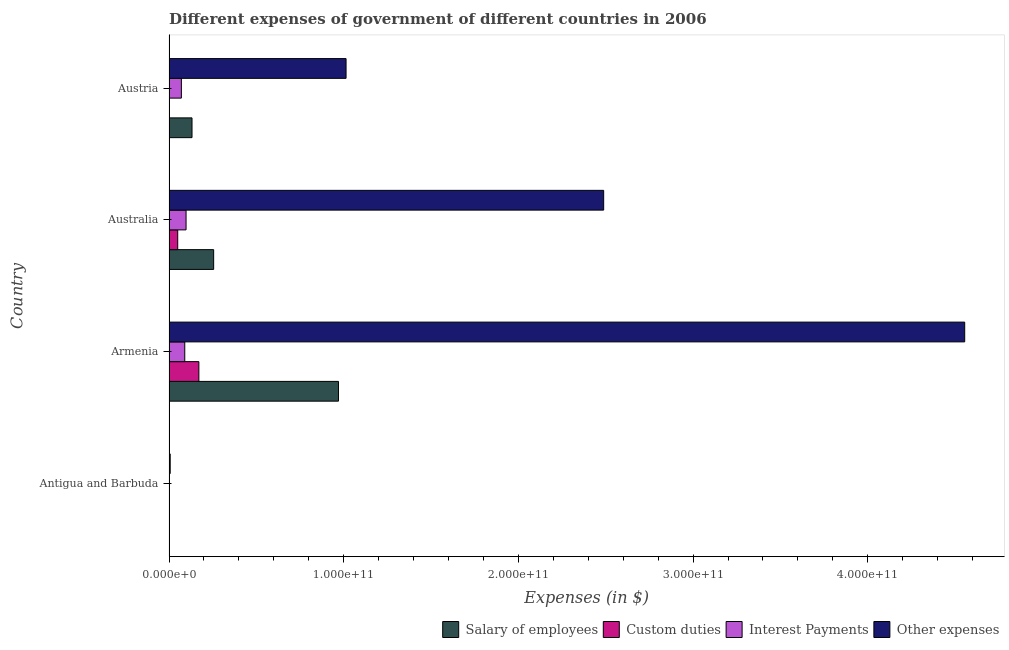How many different coloured bars are there?
Your answer should be compact. 4. How many groups of bars are there?
Keep it short and to the point. 4. Are the number of bars per tick equal to the number of legend labels?
Your answer should be very brief. Yes. Are the number of bars on each tick of the Y-axis equal?
Provide a short and direct response. Yes. In how many cases, is the number of bars for a given country not equal to the number of legend labels?
Your response must be concise. 0. What is the amount spent on custom duties in Armenia?
Make the answer very short. 1.71e+1. Across all countries, what is the maximum amount spent on custom duties?
Provide a succinct answer. 1.71e+1. Across all countries, what is the minimum amount spent on salary of employees?
Make the answer very short. 2.68e+08. In which country was the amount spent on custom duties maximum?
Your answer should be very brief. Armenia. In which country was the amount spent on other expenses minimum?
Give a very brief answer. Antigua and Barbuda. What is the total amount spent on interest payments in the graph?
Your response must be concise. 2.60e+1. What is the difference between the amount spent on custom duties in Antigua and Barbuda and that in Austria?
Give a very brief answer. 8.22e+07. What is the difference between the amount spent on interest payments in Austria and the amount spent on other expenses in Antigua and Barbuda?
Provide a short and direct response. 6.40e+09. What is the average amount spent on salary of employees per country?
Make the answer very short. 3.40e+1. What is the difference between the amount spent on salary of employees and amount spent on interest payments in Antigua and Barbuda?
Your response must be concise. 1.70e+08. In how many countries, is the amount spent on salary of employees greater than 300000000000 $?
Provide a succinct answer. 0. What is the ratio of the amount spent on interest payments in Australia to that in Austria?
Provide a succinct answer. 1.38. Is the difference between the amount spent on other expenses in Armenia and Australia greater than the difference between the amount spent on interest payments in Armenia and Australia?
Your response must be concise. Yes. What is the difference between the highest and the second highest amount spent on interest payments?
Your response must be concise. 7.39e+08. What is the difference between the highest and the lowest amount spent on custom duties?
Offer a very short reply. 1.71e+1. In how many countries, is the amount spent on other expenses greater than the average amount spent on other expenses taken over all countries?
Offer a terse response. 2. Is the sum of the amount spent on interest payments in Antigua and Barbuda and Austria greater than the maximum amount spent on other expenses across all countries?
Your answer should be compact. No. Is it the case that in every country, the sum of the amount spent on salary of employees and amount spent on interest payments is greater than the sum of amount spent on other expenses and amount spent on custom duties?
Offer a terse response. No. What does the 4th bar from the top in Antigua and Barbuda represents?
Your answer should be very brief. Salary of employees. What does the 2nd bar from the bottom in Armenia represents?
Offer a terse response. Custom duties. Is it the case that in every country, the sum of the amount spent on salary of employees and amount spent on custom duties is greater than the amount spent on interest payments?
Your response must be concise. Yes. How many bars are there?
Provide a succinct answer. 16. How many countries are there in the graph?
Offer a terse response. 4. What is the difference between two consecutive major ticks on the X-axis?
Provide a succinct answer. 1.00e+11. Does the graph contain grids?
Keep it short and to the point. No. Where does the legend appear in the graph?
Keep it short and to the point. Bottom right. How are the legend labels stacked?
Provide a short and direct response. Horizontal. What is the title of the graph?
Your answer should be compact. Different expenses of government of different countries in 2006. Does "Social Assistance" appear as one of the legend labels in the graph?
Make the answer very short. No. What is the label or title of the X-axis?
Offer a terse response. Expenses (in $). What is the label or title of the Y-axis?
Provide a succinct answer. Country. What is the Expenses (in $) of Salary of employees in Antigua and Barbuda?
Provide a short and direct response. 2.68e+08. What is the Expenses (in $) in Custom duties in Antigua and Barbuda?
Your response must be concise. 8.23e+07. What is the Expenses (in $) in Interest Payments in Antigua and Barbuda?
Provide a succinct answer. 9.81e+07. What is the Expenses (in $) in Other expenses in Antigua and Barbuda?
Make the answer very short. 6.84e+08. What is the Expenses (in $) in Salary of employees in Armenia?
Provide a succinct answer. 9.70e+1. What is the Expenses (in $) in Custom duties in Armenia?
Your answer should be compact. 1.71e+1. What is the Expenses (in $) of Interest Payments in Armenia?
Ensure brevity in your answer.  9.02e+09. What is the Expenses (in $) of Other expenses in Armenia?
Make the answer very short. 4.55e+11. What is the Expenses (in $) of Salary of employees in Australia?
Offer a terse response. 2.56e+1. What is the Expenses (in $) in Custom duties in Australia?
Keep it short and to the point. 4.99e+09. What is the Expenses (in $) of Interest Payments in Australia?
Offer a terse response. 9.76e+09. What is the Expenses (in $) in Other expenses in Australia?
Keep it short and to the point. 2.49e+11. What is the Expenses (in $) of Salary of employees in Austria?
Offer a very short reply. 1.32e+1. What is the Expenses (in $) in Custom duties in Austria?
Your answer should be compact. 7.00e+04. What is the Expenses (in $) in Interest Payments in Austria?
Make the answer very short. 7.09e+09. What is the Expenses (in $) of Other expenses in Austria?
Offer a very short reply. 1.01e+11. Across all countries, what is the maximum Expenses (in $) in Salary of employees?
Offer a very short reply. 9.70e+1. Across all countries, what is the maximum Expenses (in $) in Custom duties?
Your answer should be very brief. 1.71e+1. Across all countries, what is the maximum Expenses (in $) of Interest Payments?
Provide a succinct answer. 9.76e+09. Across all countries, what is the maximum Expenses (in $) in Other expenses?
Offer a very short reply. 4.55e+11. Across all countries, what is the minimum Expenses (in $) of Salary of employees?
Provide a short and direct response. 2.68e+08. Across all countries, what is the minimum Expenses (in $) in Interest Payments?
Your answer should be compact. 9.81e+07. Across all countries, what is the minimum Expenses (in $) in Other expenses?
Keep it short and to the point. 6.84e+08. What is the total Expenses (in $) of Salary of employees in the graph?
Provide a short and direct response. 1.36e+11. What is the total Expenses (in $) in Custom duties in the graph?
Offer a very short reply. 2.22e+1. What is the total Expenses (in $) in Interest Payments in the graph?
Offer a very short reply. 2.60e+1. What is the total Expenses (in $) of Other expenses in the graph?
Give a very brief answer. 8.06e+11. What is the difference between the Expenses (in $) in Salary of employees in Antigua and Barbuda and that in Armenia?
Offer a very short reply. -9.67e+1. What is the difference between the Expenses (in $) in Custom duties in Antigua and Barbuda and that in Armenia?
Make the answer very short. -1.70e+1. What is the difference between the Expenses (in $) of Interest Payments in Antigua and Barbuda and that in Armenia?
Offer a terse response. -8.93e+09. What is the difference between the Expenses (in $) in Other expenses in Antigua and Barbuda and that in Armenia?
Offer a very short reply. -4.55e+11. What is the difference between the Expenses (in $) in Salary of employees in Antigua and Barbuda and that in Australia?
Make the answer very short. -2.53e+1. What is the difference between the Expenses (in $) of Custom duties in Antigua and Barbuda and that in Australia?
Your response must be concise. -4.91e+09. What is the difference between the Expenses (in $) of Interest Payments in Antigua and Barbuda and that in Australia?
Keep it short and to the point. -9.67e+09. What is the difference between the Expenses (in $) in Other expenses in Antigua and Barbuda and that in Australia?
Offer a very short reply. -2.48e+11. What is the difference between the Expenses (in $) in Salary of employees in Antigua and Barbuda and that in Austria?
Give a very brief answer. -1.29e+1. What is the difference between the Expenses (in $) of Custom duties in Antigua and Barbuda and that in Austria?
Offer a terse response. 8.22e+07. What is the difference between the Expenses (in $) in Interest Payments in Antigua and Barbuda and that in Austria?
Your answer should be very brief. -6.99e+09. What is the difference between the Expenses (in $) of Other expenses in Antigua and Barbuda and that in Austria?
Keep it short and to the point. -1.01e+11. What is the difference between the Expenses (in $) of Salary of employees in Armenia and that in Australia?
Your answer should be very brief. 7.14e+1. What is the difference between the Expenses (in $) of Custom duties in Armenia and that in Australia?
Ensure brevity in your answer.  1.21e+1. What is the difference between the Expenses (in $) in Interest Payments in Armenia and that in Australia?
Provide a succinct answer. -7.39e+08. What is the difference between the Expenses (in $) in Other expenses in Armenia and that in Australia?
Your answer should be very brief. 2.07e+11. What is the difference between the Expenses (in $) in Salary of employees in Armenia and that in Austria?
Your answer should be very brief. 8.38e+1. What is the difference between the Expenses (in $) of Custom duties in Armenia and that in Austria?
Provide a short and direct response. 1.71e+1. What is the difference between the Expenses (in $) of Interest Payments in Armenia and that in Austria?
Offer a terse response. 1.94e+09. What is the difference between the Expenses (in $) of Other expenses in Armenia and that in Austria?
Provide a short and direct response. 3.54e+11. What is the difference between the Expenses (in $) in Salary of employees in Australia and that in Austria?
Keep it short and to the point. 1.24e+1. What is the difference between the Expenses (in $) in Custom duties in Australia and that in Austria?
Your response must be concise. 4.99e+09. What is the difference between the Expenses (in $) in Interest Payments in Australia and that in Austria?
Offer a terse response. 2.68e+09. What is the difference between the Expenses (in $) of Other expenses in Australia and that in Austria?
Make the answer very short. 1.47e+11. What is the difference between the Expenses (in $) of Salary of employees in Antigua and Barbuda and the Expenses (in $) of Custom duties in Armenia?
Keep it short and to the point. -1.68e+1. What is the difference between the Expenses (in $) in Salary of employees in Antigua and Barbuda and the Expenses (in $) in Interest Payments in Armenia?
Offer a terse response. -8.76e+09. What is the difference between the Expenses (in $) of Salary of employees in Antigua and Barbuda and the Expenses (in $) of Other expenses in Armenia?
Offer a very short reply. -4.55e+11. What is the difference between the Expenses (in $) in Custom duties in Antigua and Barbuda and the Expenses (in $) in Interest Payments in Armenia?
Offer a terse response. -8.94e+09. What is the difference between the Expenses (in $) of Custom duties in Antigua and Barbuda and the Expenses (in $) of Other expenses in Armenia?
Offer a very short reply. -4.55e+11. What is the difference between the Expenses (in $) of Interest Payments in Antigua and Barbuda and the Expenses (in $) of Other expenses in Armenia?
Give a very brief answer. -4.55e+11. What is the difference between the Expenses (in $) of Salary of employees in Antigua and Barbuda and the Expenses (in $) of Custom duties in Australia?
Keep it short and to the point. -4.72e+09. What is the difference between the Expenses (in $) of Salary of employees in Antigua and Barbuda and the Expenses (in $) of Interest Payments in Australia?
Your response must be concise. -9.50e+09. What is the difference between the Expenses (in $) in Salary of employees in Antigua and Barbuda and the Expenses (in $) in Other expenses in Australia?
Give a very brief answer. -2.49e+11. What is the difference between the Expenses (in $) in Custom duties in Antigua and Barbuda and the Expenses (in $) in Interest Payments in Australia?
Offer a very short reply. -9.68e+09. What is the difference between the Expenses (in $) in Custom duties in Antigua and Barbuda and the Expenses (in $) in Other expenses in Australia?
Your answer should be very brief. -2.49e+11. What is the difference between the Expenses (in $) of Interest Payments in Antigua and Barbuda and the Expenses (in $) of Other expenses in Australia?
Provide a succinct answer. -2.49e+11. What is the difference between the Expenses (in $) of Salary of employees in Antigua and Barbuda and the Expenses (in $) of Custom duties in Austria?
Ensure brevity in your answer.  2.68e+08. What is the difference between the Expenses (in $) of Salary of employees in Antigua and Barbuda and the Expenses (in $) of Interest Payments in Austria?
Your answer should be very brief. -6.82e+09. What is the difference between the Expenses (in $) in Salary of employees in Antigua and Barbuda and the Expenses (in $) in Other expenses in Austria?
Your answer should be compact. -1.01e+11. What is the difference between the Expenses (in $) in Custom duties in Antigua and Barbuda and the Expenses (in $) in Interest Payments in Austria?
Your answer should be compact. -7.00e+09. What is the difference between the Expenses (in $) of Custom duties in Antigua and Barbuda and the Expenses (in $) of Other expenses in Austria?
Offer a very short reply. -1.01e+11. What is the difference between the Expenses (in $) of Interest Payments in Antigua and Barbuda and the Expenses (in $) of Other expenses in Austria?
Offer a terse response. -1.01e+11. What is the difference between the Expenses (in $) of Salary of employees in Armenia and the Expenses (in $) of Custom duties in Australia?
Your response must be concise. 9.20e+1. What is the difference between the Expenses (in $) in Salary of employees in Armenia and the Expenses (in $) in Interest Payments in Australia?
Your answer should be compact. 8.72e+1. What is the difference between the Expenses (in $) in Salary of employees in Armenia and the Expenses (in $) in Other expenses in Australia?
Provide a succinct answer. -1.52e+11. What is the difference between the Expenses (in $) of Custom duties in Armenia and the Expenses (in $) of Interest Payments in Australia?
Provide a short and direct response. 7.34e+09. What is the difference between the Expenses (in $) of Custom duties in Armenia and the Expenses (in $) of Other expenses in Australia?
Your answer should be very brief. -2.32e+11. What is the difference between the Expenses (in $) of Interest Payments in Armenia and the Expenses (in $) of Other expenses in Australia?
Keep it short and to the point. -2.40e+11. What is the difference between the Expenses (in $) in Salary of employees in Armenia and the Expenses (in $) in Custom duties in Austria?
Provide a succinct answer. 9.70e+1. What is the difference between the Expenses (in $) of Salary of employees in Armenia and the Expenses (in $) of Interest Payments in Austria?
Your response must be concise. 8.99e+1. What is the difference between the Expenses (in $) of Salary of employees in Armenia and the Expenses (in $) of Other expenses in Austria?
Offer a very short reply. -4.35e+09. What is the difference between the Expenses (in $) of Custom duties in Armenia and the Expenses (in $) of Interest Payments in Austria?
Your answer should be compact. 1.00e+1. What is the difference between the Expenses (in $) in Custom duties in Armenia and the Expenses (in $) in Other expenses in Austria?
Keep it short and to the point. -8.43e+1. What is the difference between the Expenses (in $) in Interest Payments in Armenia and the Expenses (in $) in Other expenses in Austria?
Your answer should be compact. -9.23e+1. What is the difference between the Expenses (in $) of Salary of employees in Australia and the Expenses (in $) of Custom duties in Austria?
Provide a succinct answer. 2.56e+1. What is the difference between the Expenses (in $) of Salary of employees in Australia and the Expenses (in $) of Interest Payments in Austria?
Your answer should be compact. 1.85e+1. What is the difference between the Expenses (in $) of Salary of employees in Australia and the Expenses (in $) of Other expenses in Austria?
Ensure brevity in your answer.  -7.58e+1. What is the difference between the Expenses (in $) of Custom duties in Australia and the Expenses (in $) of Interest Payments in Austria?
Your response must be concise. -2.10e+09. What is the difference between the Expenses (in $) in Custom duties in Australia and the Expenses (in $) in Other expenses in Austria?
Provide a succinct answer. -9.64e+1. What is the difference between the Expenses (in $) of Interest Payments in Australia and the Expenses (in $) of Other expenses in Austria?
Ensure brevity in your answer.  -9.16e+1. What is the average Expenses (in $) of Salary of employees per country?
Your response must be concise. 3.40e+1. What is the average Expenses (in $) of Custom duties per country?
Your response must be concise. 5.54e+09. What is the average Expenses (in $) in Interest Payments per country?
Offer a terse response. 6.49e+09. What is the average Expenses (in $) of Other expenses per country?
Your answer should be compact. 2.02e+11. What is the difference between the Expenses (in $) of Salary of employees and Expenses (in $) of Custom duties in Antigua and Barbuda?
Offer a very short reply. 1.86e+08. What is the difference between the Expenses (in $) of Salary of employees and Expenses (in $) of Interest Payments in Antigua and Barbuda?
Offer a very short reply. 1.70e+08. What is the difference between the Expenses (in $) in Salary of employees and Expenses (in $) in Other expenses in Antigua and Barbuda?
Your response must be concise. -4.16e+08. What is the difference between the Expenses (in $) in Custom duties and Expenses (in $) in Interest Payments in Antigua and Barbuda?
Give a very brief answer. -1.58e+07. What is the difference between the Expenses (in $) of Custom duties and Expenses (in $) of Other expenses in Antigua and Barbuda?
Ensure brevity in your answer.  -6.02e+08. What is the difference between the Expenses (in $) of Interest Payments and Expenses (in $) of Other expenses in Antigua and Barbuda?
Your response must be concise. -5.86e+08. What is the difference between the Expenses (in $) in Salary of employees and Expenses (in $) in Custom duties in Armenia?
Offer a very short reply. 7.99e+1. What is the difference between the Expenses (in $) in Salary of employees and Expenses (in $) in Interest Payments in Armenia?
Your answer should be very brief. 8.80e+1. What is the difference between the Expenses (in $) of Salary of employees and Expenses (in $) of Other expenses in Armenia?
Ensure brevity in your answer.  -3.58e+11. What is the difference between the Expenses (in $) in Custom duties and Expenses (in $) in Interest Payments in Armenia?
Provide a short and direct response. 8.08e+09. What is the difference between the Expenses (in $) of Custom duties and Expenses (in $) of Other expenses in Armenia?
Provide a succinct answer. -4.38e+11. What is the difference between the Expenses (in $) of Interest Payments and Expenses (in $) of Other expenses in Armenia?
Give a very brief answer. -4.46e+11. What is the difference between the Expenses (in $) in Salary of employees and Expenses (in $) in Custom duties in Australia?
Ensure brevity in your answer.  2.06e+1. What is the difference between the Expenses (in $) in Salary of employees and Expenses (in $) in Interest Payments in Australia?
Offer a very short reply. 1.58e+1. What is the difference between the Expenses (in $) of Salary of employees and Expenses (in $) of Other expenses in Australia?
Give a very brief answer. -2.23e+11. What is the difference between the Expenses (in $) in Custom duties and Expenses (in $) in Interest Payments in Australia?
Provide a succinct answer. -4.78e+09. What is the difference between the Expenses (in $) of Custom duties and Expenses (in $) of Other expenses in Australia?
Your answer should be very brief. -2.44e+11. What is the difference between the Expenses (in $) in Interest Payments and Expenses (in $) in Other expenses in Australia?
Make the answer very short. -2.39e+11. What is the difference between the Expenses (in $) in Salary of employees and Expenses (in $) in Custom duties in Austria?
Your answer should be very brief. 1.32e+1. What is the difference between the Expenses (in $) in Salary of employees and Expenses (in $) in Interest Payments in Austria?
Give a very brief answer. 6.09e+09. What is the difference between the Expenses (in $) in Salary of employees and Expenses (in $) in Other expenses in Austria?
Ensure brevity in your answer.  -8.82e+1. What is the difference between the Expenses (in $) of Custom duties and Expenses (in $) of Interest Payments in Austria?
Offer a very short reply. -7.09e+09. What is the difference between the Expenses (in $) in Custom duties and Expenses (in $) in Other expenses in Austria?
Provide a succinct answer. -1.01e+11. What is the difference between the Expenses (in $) in Interest Payments and Expenses (in $) in Other expenses in Austria?
Your answer should be compact. -9.43e+1. What is the ratio of the Expenses (in $) in Salary of employees in Antigua and Barbuda to that in Armenia?
Your answer should be compact. 0. What is the ratio of the Expenses (in $) of Custom duties in Antigua and Barbuda to that in Armenia?
Offer a very short reply. 0. What is the ratio of the Expenses (in $) of Interest Payments in Antigua and Barbuda to that in Armenia?
Make the answer very short. 0.01. What is the ratio of the Expenses (in $) of Other expenses in Antigua and Barbuda to that in Armenia?
Ensure brevity in your answer.  0. What is the ratio of the Expenses (in $) in Salary of employees in Antigua and Barbuda to that in Australia?
Give a very brief answer. 0.01. What is the ratio of the Expenses (in $) in Custom duties in Antigua and Barbuda to that in Australia?
Provide a short and direct response. 0.02. What is the ratio of the Expenses (in $) of Interest Payments in Antigua and Barbuda to that in Australia?
Your response must be concise. 0.01. What is the ratio of the Expenses (in $) of Other expenses in Antigua and Barbuda to that in Australia?
Your answer should be compact. 0. What is the ratio of the Expenses (in $) of Salary of employees in Antigua and Barbuda to that in Austria?
Ensure brevity in your answer.  0.02. What is the ratio of the Expenses (in $) of Custom duties in Antigua and Barbuda to that in Austria?
Your answer should be very brief. 1175.71. What is the ratio of the Expenses (in $) of Interest Payments in Antigua and Barbuda to that in Austria?
Make the answer very short. 0.01. What is the ratio of the Expenses (in $) of Other expenses in Antigua and Barbuda to that in Austria?
Offer a terse response. 0.01. What is the ratio of the Expenses (in $) of Salary of employees in Armenia to that in Australia?
Your answer should be compact. 3.79. What is the ratio of the Expenses (in $) of Custom duties in Armenia to that in Australia?
Ensure brevity in your answer.  3.43. What is the ratio of the Expenses (in $) of Interest Payments in Armenia to that in Australia?
Offer a very short reply. 0.92. What is the ratio of the Expenses (in $) in Other expenses in Armenia to that in Australia?
Make the answer very short. 1.83. What is the ratio of the Expenses (in $) in Salary of employees in Armenia to that in Austria?
Make the answer very short. 7.36. What is the ratio of the Expenses (in $) in Custom duties in Armenia to that in Austria?
Offer a very short reply. 2.44e+05. What is the ratio of the Expenses (in $) in Interest Payments in Armenia to that in Austria?
Ensure brevity in your answer.  1.27. What is the ratio of the Expenses (in $) in Other expenses in Armenia to that in Austria?
Keep it short and to the point. 4.49. What is the ratio of the Expenses (in $) of Salary of employees in Australia to that in Austria?
Keep it short and to the point. 1.94. What is the ratio of the Expenses (in $) in Custom duties in Australia to that in Austria?
Your response must be concise. 7.13e+04. What is the ratio of the Expenses (in $) of Interest Payments in Australia to that in Austria?
Your response must be concise. 1.38. What is the ratio of the Expenses (in $) in Other expenses in Australia to that in Austria?
Your answer should be very brief. 2.45. What is the difference between the highest and the second highest Expenses (in $) in Salary of employees?
Make the answer very short. 7.14e+1. What is the difference between the highest and the second highest Expenses (in $) of Custom duties?
Provide a succinct answer. 1.21e+1. What is the difference between the highest and the second highest Expenses (in $) of Interest Payments?
Offer a very short reply. 7.39e+08. What is the difference between the highest and the second highest Expenses (in $) of Other expenses?
Give a very brief answer. 2.07e+11. What is the difference between the highest and the lowest Expenses (in $) of Salary of employees?
Provide a succinct answer. 9.67e+1. What is the difference between the highest and the lowest Expenses (in $) in Custom duties?
Your response must be concise. 1.71e+1. What is the difference between the highest and the lowest Expenses (in $) in Interest Payments?
Your answer should be compact. 9.67e+09. What is the difference between the highest and the lowest Expenses (in $) in Other expenses?
Offer a terse response. 4.55e+11. 